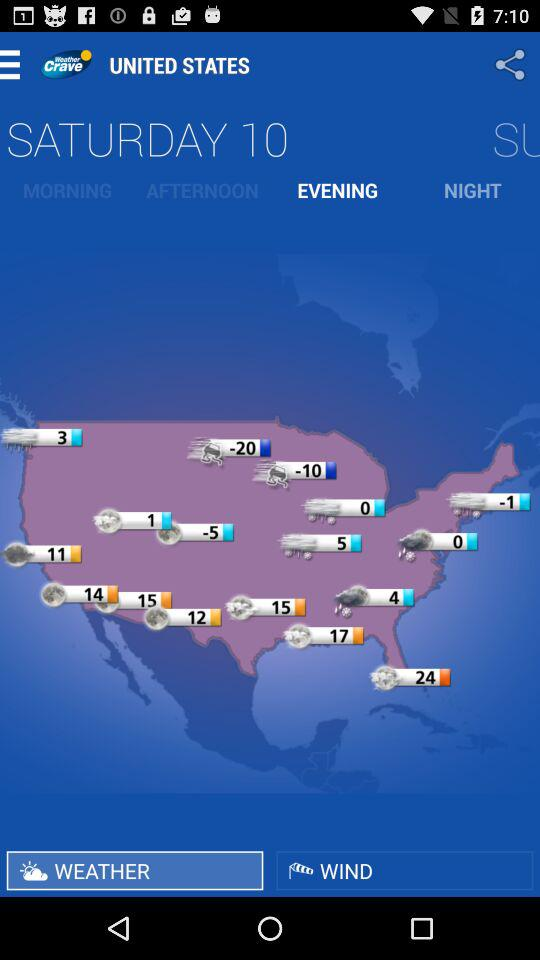Which tab is selected? The selected tabs are "EVENING" and "WEATHER". 